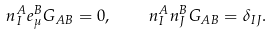Convert formula to latex. <formula><loc_0><loc_0><loc_500><loc_500>n ^ { A } _ { I } e ^ { B } _ { \mu } G _ { A B } = 0 , \quad n ^ { A } _ { I } n ^ { B } _ { J } G _ { A B } = \delta _ { I J } . \</formula> 